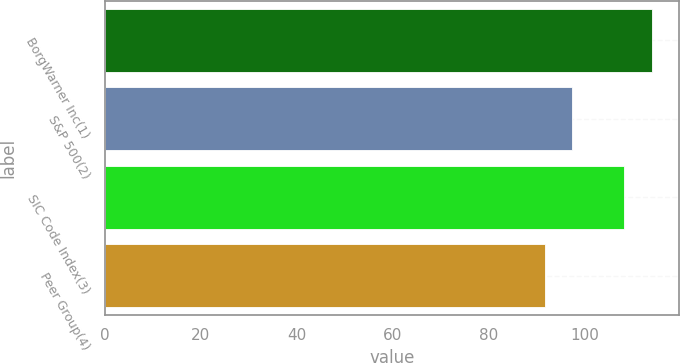Convert chart. <chart><loc_0><loc_0><loc_500><loc_500><bar_chart><fcel>BorgWarner Inc(1)<fcel>S&P 500(2)<fcel>SIC Code Index(3)<fcel>Peer Group(4)<nl><fcel>113.86<fcel>97.33<fcel>108.22<fcel>91.74<nl></chart> 